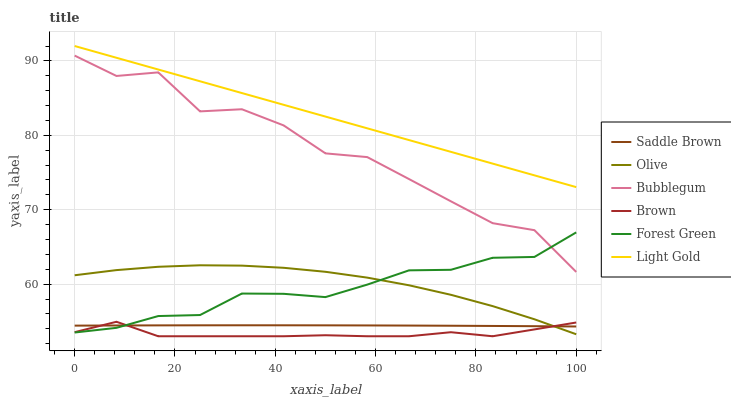Does Brown have the minimum area under the curve?
Answer yes or no. Yes. Does Light Gold have the maximum area under the curve?
Answer yes or no. Yes. Does Bubblegum have the minimum area under the curve?
Answer yes or no. No. Does Bubblegum have the maximum area under the curve?
Answer yes or no. No. Is Light Gold the smoothest?
Answer yes or no. Yes. Is Bubblegum the roughest?
Answer yes or no. Yes. Is Forest Green the smoothest?
Answer yes or no. No. Is Forest Green the roughest?
Answer yes or no. No. Does Bubblegum have the lowest value?
Answer yes or no. No. Does Light Gold have the highest value?
Answer yes or no. Yes. Does Bubblegum have the highest value?
Answer yes or no. No. Is Olive less than Light Gold?
Answer yes or no. Yes. Is Light Gold greater than Bubblegum?
Answer yes or no. Yes. Does Forest Green intersect Saddle Brown?
Answer yes or no. Yes. Is Forest Green less than Saddle Brown?
Answer yes or no. No. Is Forest Green greater than Saddle Brown?
Answer yes or no. No. Does Olive intersect Light Gold?
Answer yes or no. No. 